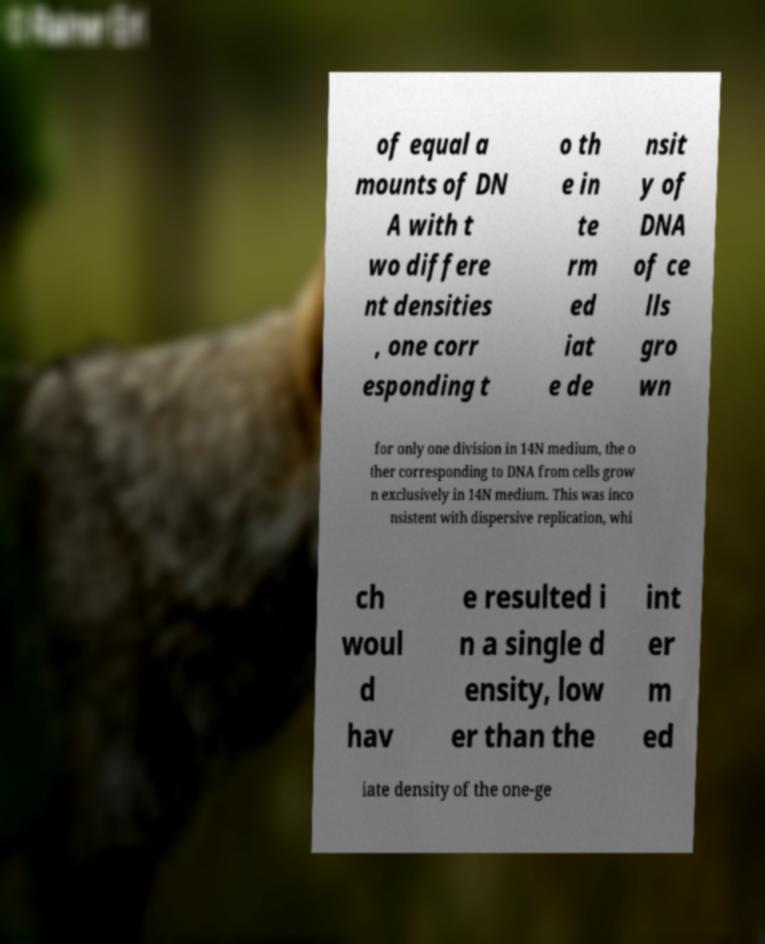Please identify and transcribe the text found in this image. of equal a mounts of DN A with t wo differe nt densities , one corr esponding t o th e in te rm ed iat e de nsit y of DNA of ce lls gro wn for only one division in 14N medium, the o ther corresponding to DNA from cells grow n exclusively in 14N medium. This was inco nsistent with dispersive replication, whi ch woul d hav e resulted i n a single d ensity, low er than the int er m ed iate density of the one-ge 